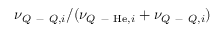<formula> <loc_0><loc_0><loc_500><loc_500>\nu _ { Q - Q , i } / ( \nu _ { Q - H e , i } + \nu _ { Q - Q , i } )</formula> 